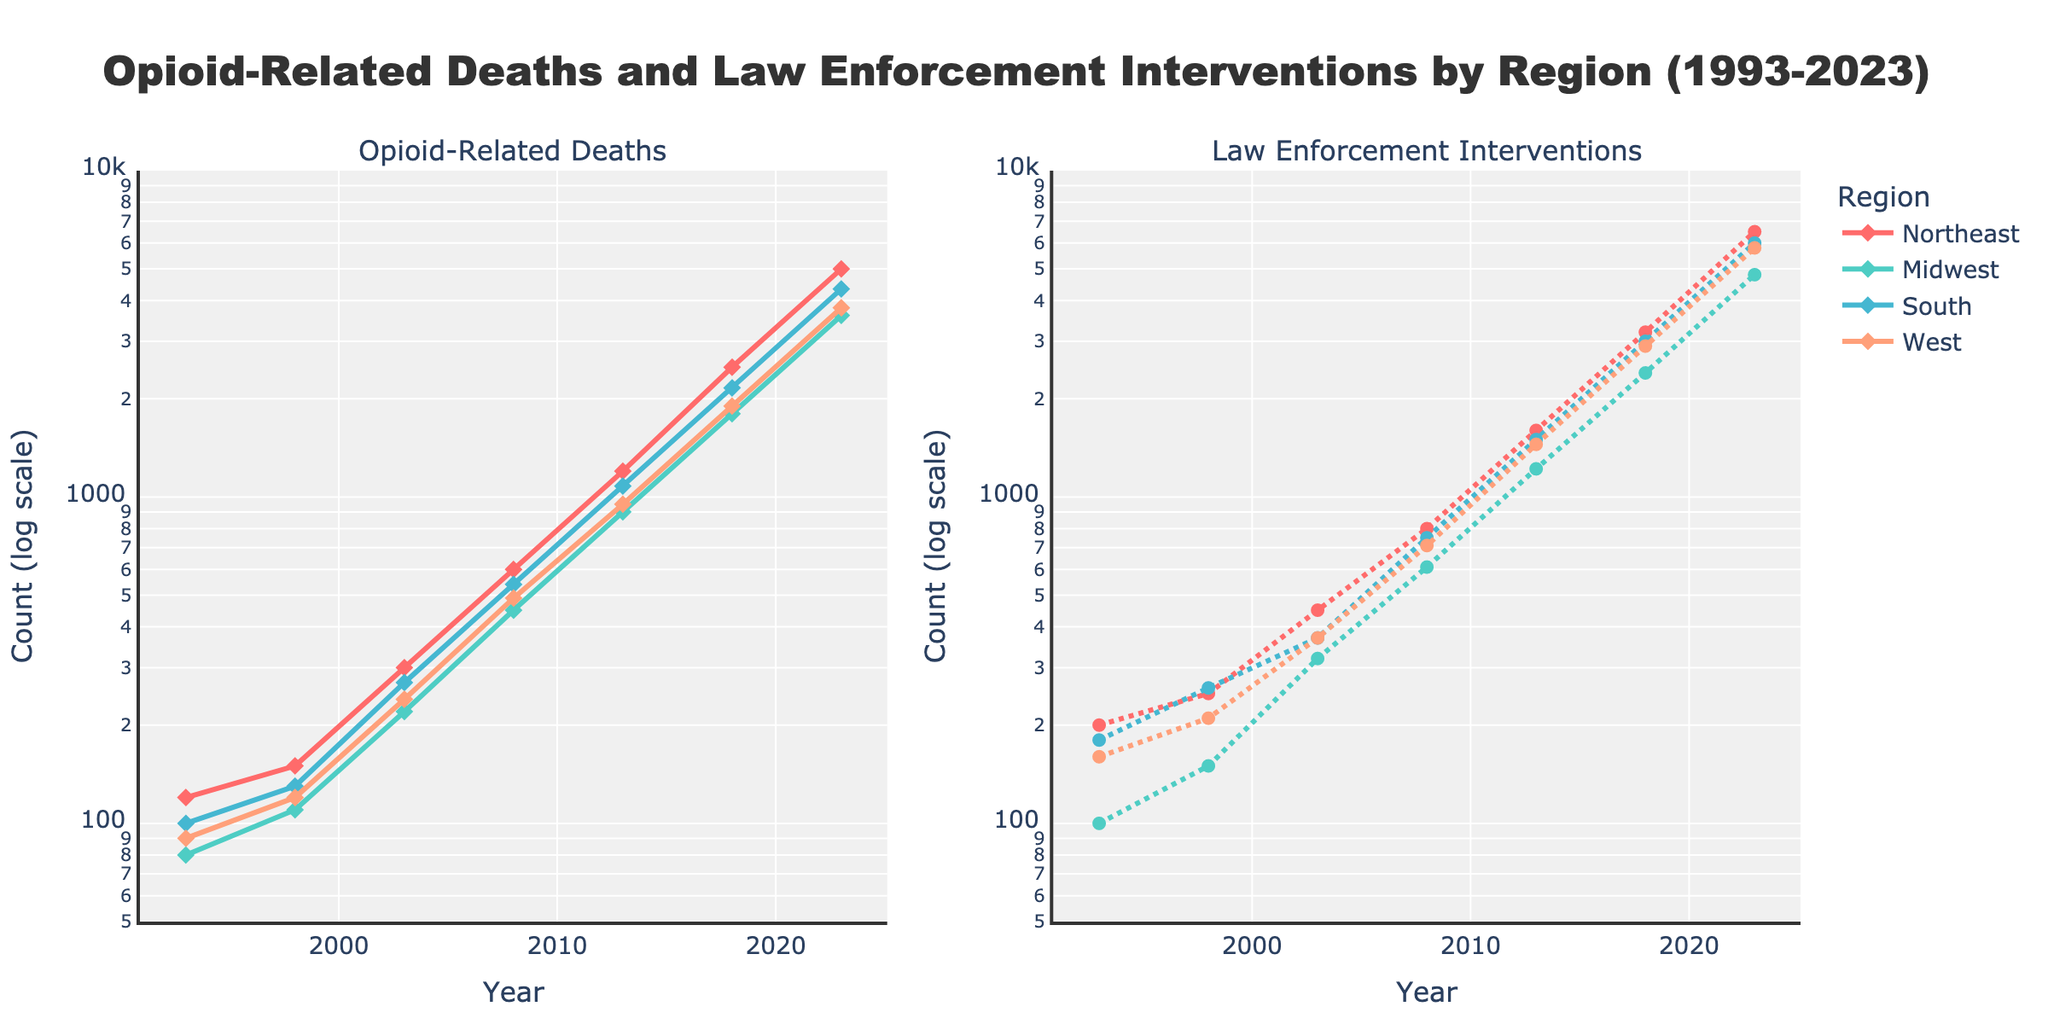What is the title of the figure? The title of a figure is usually located at the top of the plot and summarizes the main topic or data displayed in the figure.
Answer: Opioid-Related Deaths and Law Enforcement Interventions by Region (1993-2023) Which region had the highest number of opioid-related deaths in 2023? Look at the left plot and identify the highest data point on the y-axis for the year 2023. The corresponding region will be labeled in the legend.
Answer: Northeast How do the overall trends in law enforcement interventions compare between the Northeast and the Midwest from 1993 to 2023? Observe the right plot and trace the two lines representing the Northeast and Midwest regions. Compare the patterns and magnitude of increases in law enforcement interventions over the years.
Answer: Both Northeast and Midwest show increasing trends, but the Northeast consistently has higher counts What is the approximate difference in opioid-related deaths in the South between 2003 and 2013? Locate the data points for the South region in 2003 and 2013 on the left plot, and then subtract the 2003 value from the 2013 value.
Answer: 810 What is the general shape of the trend in opioid-related deaths across all regions from 1993 to 2023? Look at the general pattern of all the lines in the left plot to describe the overall trend shape, ignoring minor fluctuations.
Answer: Exponential increase How does the increase in law enforcement interventions in the West compare to the South between 2013 and 2023? On the right plot, find the values for the West and South regions in both 2013 and 2023, then calculate the differences and compare them.
Answer: The West increased by 4350, and the South increased by 4500, both showing similar increases Which region shows the steepest increase in opioid-related deaths during the period 1998-2008? Examine the slope of each region's line on the left plot between 1998 and 2008 to determine which one increases the fastest.
Answer: Northeast Are the patterns in opioid-related deaths and law enforcement interventions correlated across all regions? Compare the trends in both left and right plots to see if increases in opioid-related deaths correspond to increases in law enforcement interventions.
Answer: Yes What was the count of law enforcement interventions in the Midwest in 2008? Locate the corresponding data point for the Midwest region in the right plot for the year 2008.
Answer: 610 